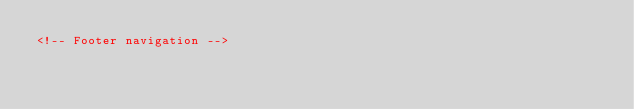<code> <loc_0><loc_0><loc_500><loc_500><_HTML_><!-- Footer navigation --></code> 